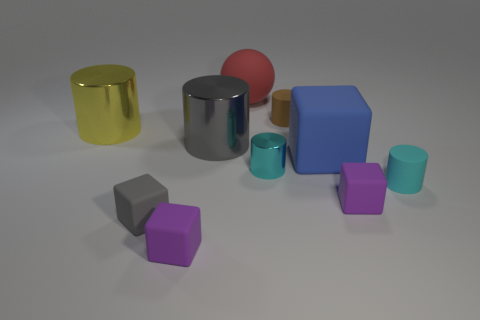How big is the cylinder that is on the left side of the big red matte object and in front of the yellow metal object?
Your answer should be compact. Large. What number of blocks are the same size as the brown thing?
Offer a terse response. 3. How many tiny purple objects are to the left of the tiny cyan cylinder to the left of the tiny cyan rubber cylinder?
Offer a very short reply. 1. There is a metallic thing behind the large gray thing; is it the same color as the small shiny object?
Provide a short and direct response. No. Is there a small thing to the right of the small purple rubber thing that is in front of the purple thing right of the big matte cube?
Your answer should be compact. Yes. The big thing that is both to the right of the large yellow metallic object and left of the big red ball has what shape?
Give a very brief answer. Cylinder. Are there any tiny matte cubes that have the same color as the big rubber cube?
Your response must be concise. No. What color is the cube behind the shiny thing right of the red thing?
Keep it short and to the point. Blue. There is a thing that is left of the gray rubber cube that is in front of the purple rubber object that is to the right of the cyan metal thing; what is its size?
Provide a short and direct response. Large. Does the brown thing have the same material as the gray thing behind the blue rubber object?
Give a very brief answer. No. 